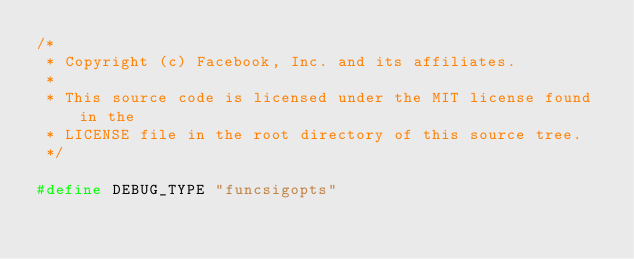<code> <loc_0><loc_0><loc_500><loc_500><_C++_>/*
 * Copyright (c) Facebook, Inc. and its affiliates.
 *
 * This source code is licensed under the MIT license found in the
 * LICENSE file in the root directory of this source tree.
 */

#define DEBUG_TYPE "funcsigopts"
</code> 